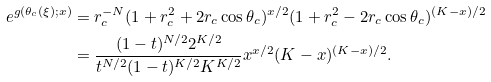<formula> <loc_0><loc_0><loc_500><loc_500>e ^ { g ( \theta _ { c } ( \xi ) ; x ) } & = r _ { c } ^ { - N } ( 1 + r _ { c } ^ { 2 } + 2 r _ { c } \cos \theta _ { c } ) ^ { x / 2 } ( 1 + r _ { c } ^ { 2 } - 2 r _ { c } \cos \theta _ { c } ) ^ { ( K - x ) / 2 } \\ & = \frac { ( 1 - t ) ^ { N / 2 } 2 ^ { K / 2 } } { t ^ { N / 2 } ( 1 - t ) ^ { K / 2 } K ^ { K / 2 } } x ^ { x / 2 } ( K - x ) ^ { ( K - x ) / 2 } .</formula> 